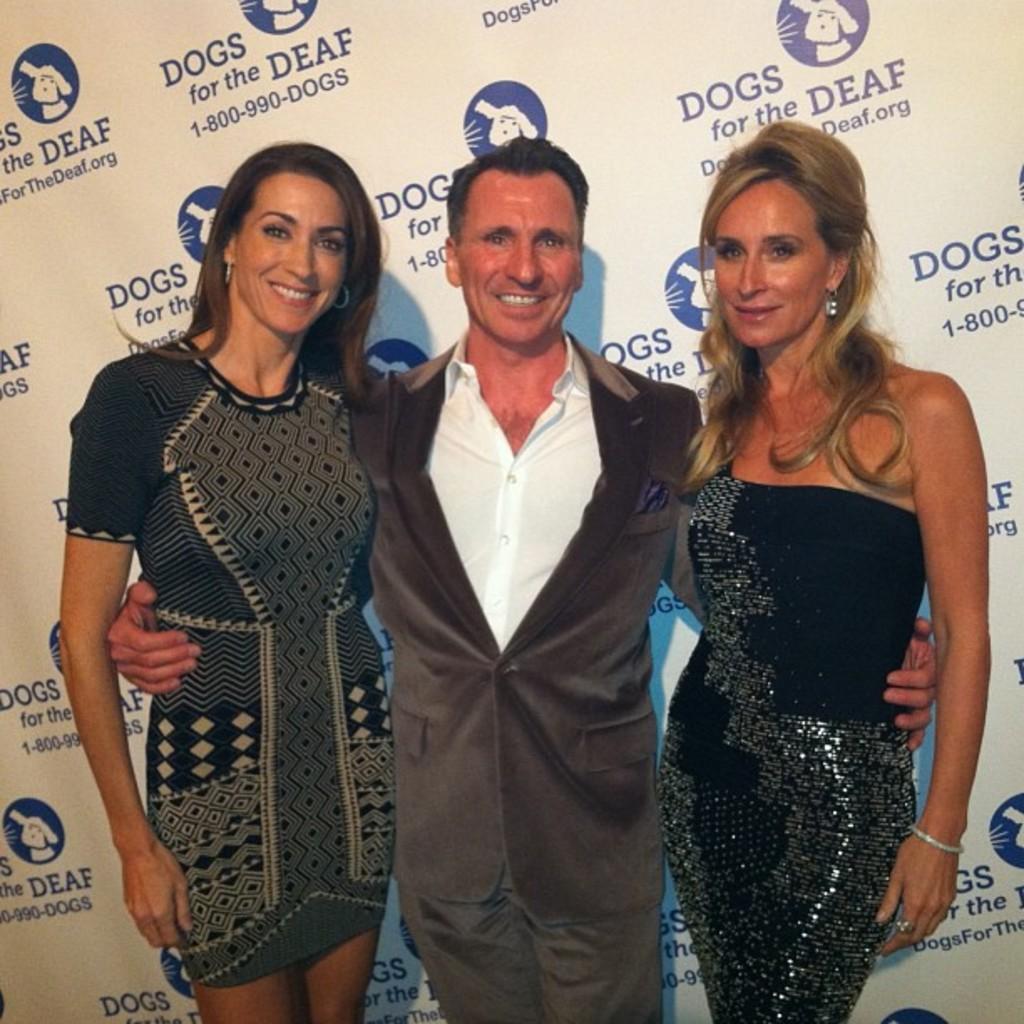In one or two sentences, can you explain what this image depicts? This picture shows a couple of women and a man standing and we see a hoarding on the back and we see smile on their faces. 